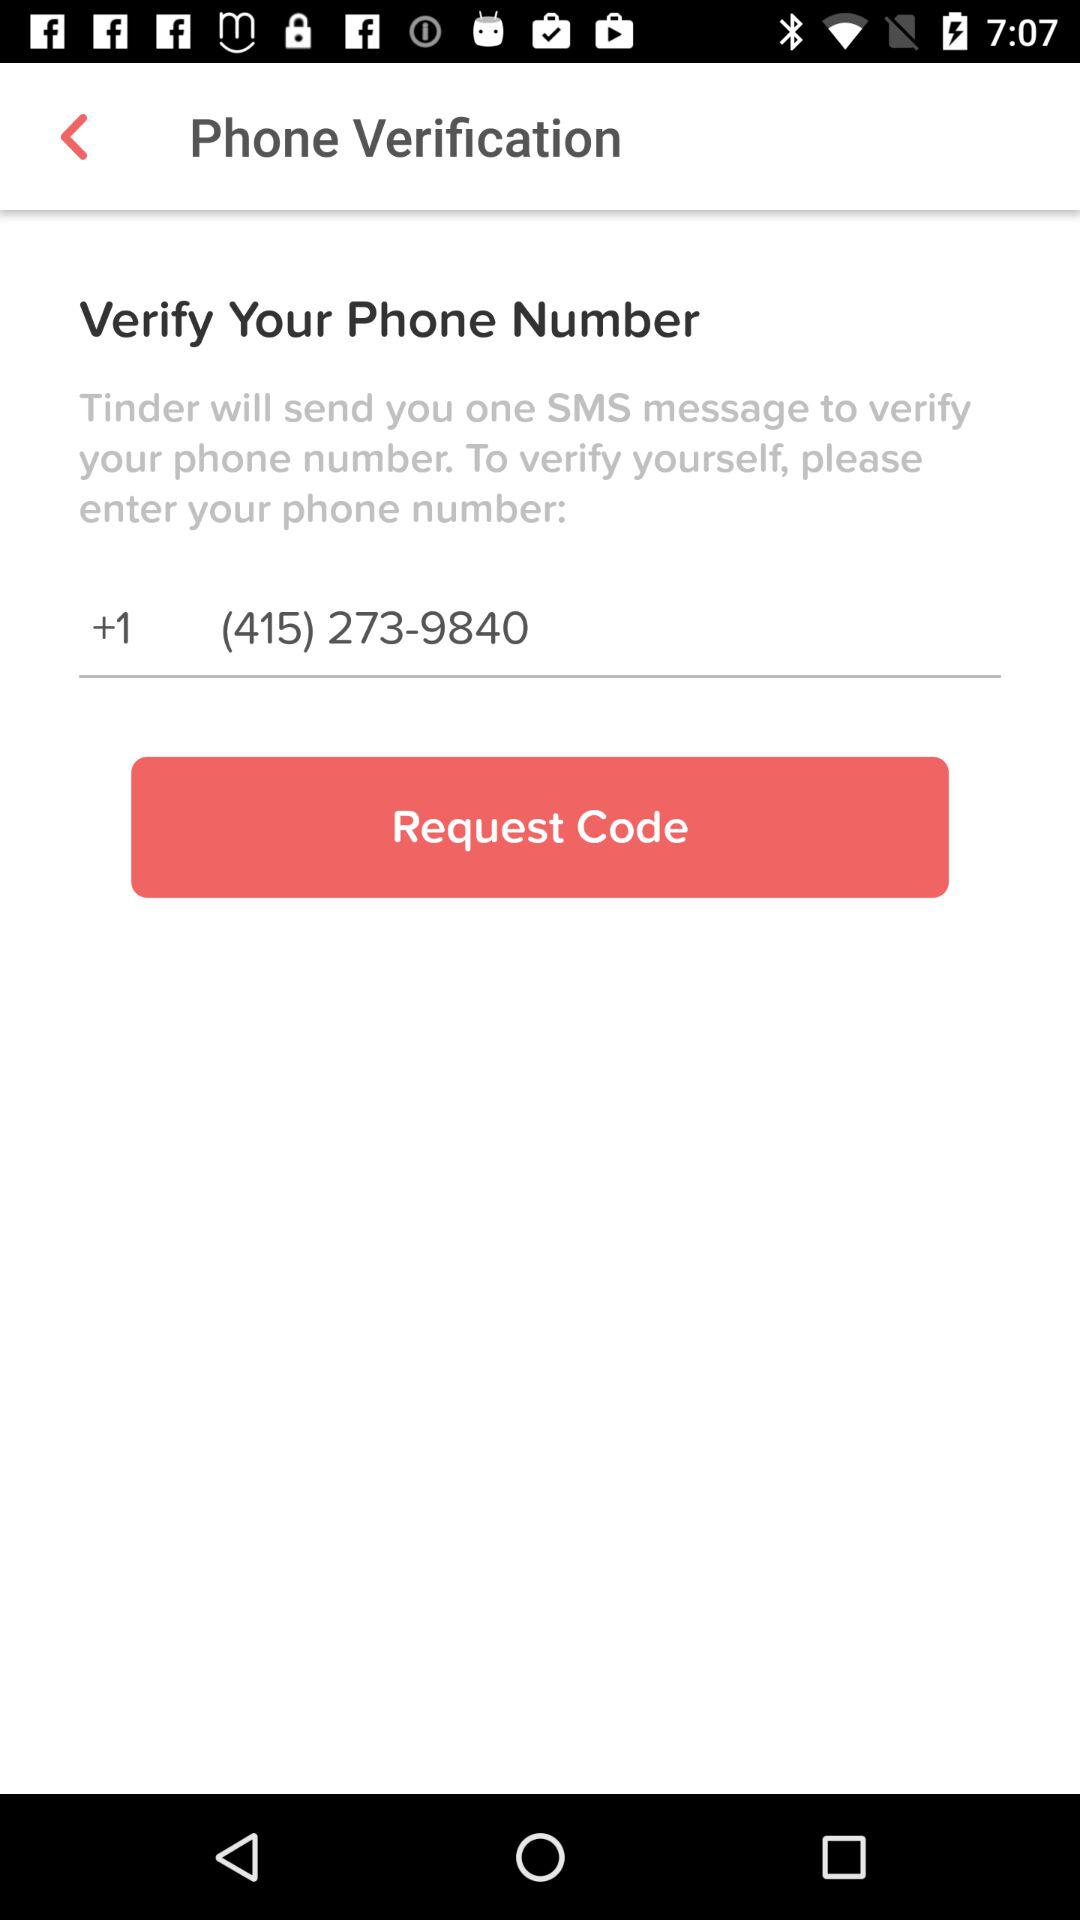What phone number is being used for verification? The phone number being used for verification is (415) 273-9840. 